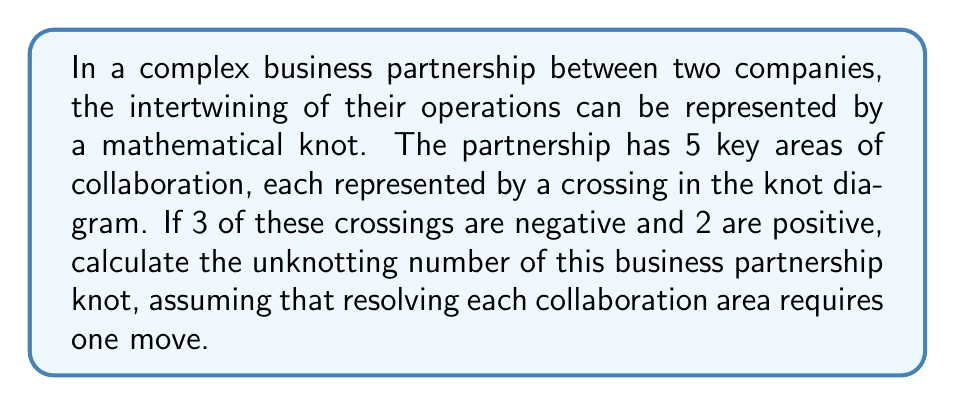Can you answer this question? To solve this problem, we need to understand the concept of unknotting number in knot theory and how it applies to our business partnership scenario.

Step 1: Understand the unknotting number
The unknotting number of a knot is the minimum number of crossing changes required to transform the knot into an unknot (a simple closed loop).

Step 2: Analyze the given information
- Total crossings: 5
- Negative crossings: 3
- Positive crossings: 2

Step 3: Calculate the writhe of the knot
The writhe of a knot is the sum of the signs of its crossings.
Writhe = (Number of positive crossings) - (Number of negative crossings)
$$W = 2 - 3 = -1$$

Step 4: Determine the unknotting number
In this case, the unknotting number is the minimum of:
a) The number of negative crossings: 3
b) The number of positive crossings: 2
c) The absolute value of half the writhe: $|\frac{W}{2}| = |\frac{-1}{2}| = \frac{1}{2}$

Therefore, the unknotting number is:
$$u = \min(3, 2, \frac{1}{2}) = \frac{1}{2}$$

Step 5: Interpret the result
Since we're dealing with discrete business collaboration areas, we need to round up to the nearest whole number.

Final unknotting number: $\lceil \frac{1}{2} \rceil = 1$

This means that resolving one key area of collaboration (changing one crossing) is sufficient to "unknot" the complex business partnership.
Answer: 1 